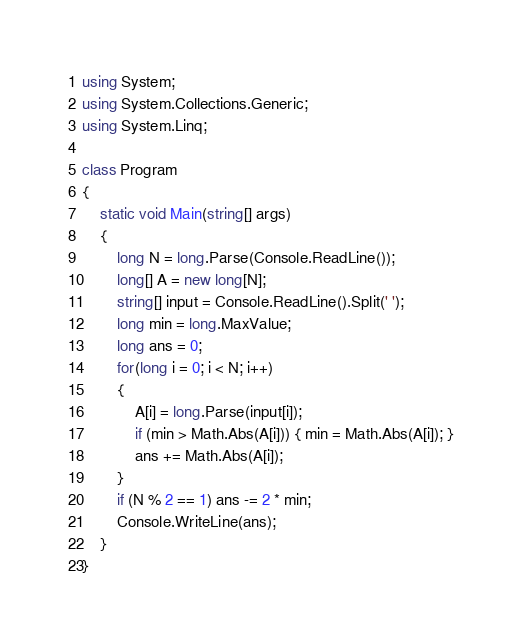<code> <loc_0><loc_0><loc_500><loc_500><_C#_>using System;
using System.Collections.Generic;
using System.Linq;

class Program
{
    static void Main(string[] args)
    {
        long N = long.Parse(Console.ReadLine());
        long[] A = new long[N];
        string[] input = Console.ReadLine().Split(' ');
        long min = long.MaxValue;
        long ans = 0;
        for(long i = 0; i < N; i++)
        {
            A[i] = long.Parse(input[i]);
            if (min > Math.Abs(A[i])) { min = Math.Abs(A[i]); }
            ans += Math.Abs(A[i]);
        }
        if (N % 2 == 1) ans -= 2 * min;
        Console.WriteLine(ans);
    }
}</code> 